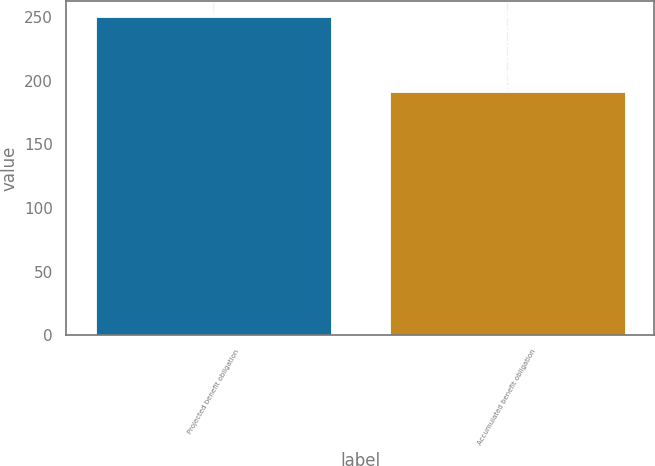<chart> <loc_0><loc_0><loc_500><loc_500><bar_chart><fcel>Projected benefit obligation<fcel>Accumulated benefit obligation<nl><fcel>250<fcel>191<nl></chart> 